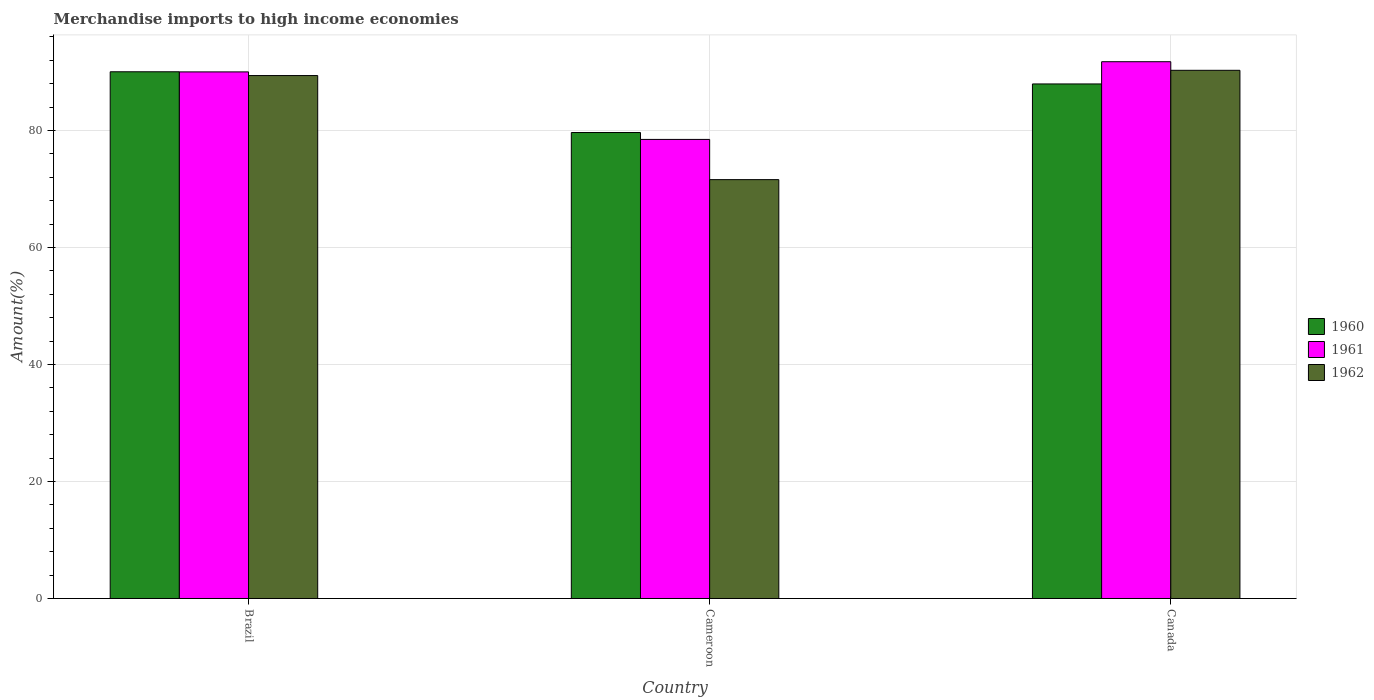How many groups of bars are there?
Provide a short and direct response. 3. Are the number of bars per tick equal to the number of legend labels?
Offer a very short reply. Yes. Are the number of bars on each tick of the X-axis equal?
Provide a short and direct response. Yes. How many bars are there on the 3rd tick from the left?
Your answer should be very brief. 3. In how many cases, is the number of bars for a given country not equal to the number of legend labels?
Give a very brief answer. 0. What is the percentage of amount earned from merchandise imports in 1962 in Brazil?
Ensure brevity in your answer.  89.41. Across all countries, what is the maximum percentage of amount earned from merchandise imports in 1960?
Offer a terse response. 90.05. Across all countries, what is the minimum percentage of amount earned from merchandise imports in 1961?
Provide a short and direct response. 78.49. In which country was the percentage of amount earned from merchandise imports in 1960 maximum?
Provide a succinct answer. Brazil. In which country was the percentage of amount earned from merchandise imports in 1962 minimum?
Your answer should be very brief. Cameroon. What is the total percentage of amount earned from merchandise imports in 1962 in the graph?
Your answer should be compact. 251.32. What is the difference between the percentage of amount earned from merchandise imports in 1962 in Brazil and that in Canada?
Provide a succinct answer. -0.9. What is the difference between the percentage of amount earned from merchandise imports in 1962 in Cameroon and the percentage of amount earned from merchandise imports in 1961 in Brazil?
Keep it short and to the point. -18.42. What is the average percentage of amount earned from merchandise imports in 1961 per country?
Give a very brief answer. 86.76. What is the difference between the percentage of amount earned from merchandise imports of/in 1961 and percentage of amount earned from merchandise imports of/in 1962 in Brazil?
Your response must be concise. 0.62. In how many countries, is the percentage of amount earned from merchandise imports in 1962 greater than 32 %?
Ensure brevity in your answer.  3. What is the ratio of the percentage of amount earned from merchandise imports in 1962 in Cameroon to that in Canada?
Give a very brief answer. 0.79. Is the percentage of amount earned from merchandise imports in 1961 in Brazil less than that in Cameroon?
Ensure brevity in your answer.  No. What is the difference between the highest and the second highest percentage of amount earned from merchandise imports in 1961?
Offer a terse response. -1.74. What is the difference between the highest and the lowest percentage of amount earned from merchandise imports in 1962?
Make the answer very short. 18.69. Is the sum of the percentage of amount earned from merchandise imports in 1962 in Brazil and Canada greater than the maximum percentage of amount earned from merchandise imports in 1960 across all countries?
Provide a short and direct response. Yes. Are all the bars in the graph horizontal?
Provide a succinct answer. No. What is the difference between two consecutive major ticks on the Y-axis?
Your answer should be very brief. 20. Are the values on the major ticks of Y-axis written in scientific E-notation?
Make the answer very short. No. What is the title of the graph?
Ensure brevity in your answer.  Merchandise imports to high income economies. Does "1988" appear as one of the legend labels in the graph?
Your answer should be very brief. No. What is the label or title of the X-axis?
Offer a very short reply. Country. What is the label or title of the Y-axis?
Your answer should be very brief. Amount(%). What is the Amount(%) in 1960 in Brazil?
Make the answer very short. 90.05. What is the Amount(%) in 1961 in Brazil?
Your answer should be very brief. 90.03. What is the Amount(%) in 1962 in Brazil?
Your response must be concise. 89.41. What is the Amount(%) in 1960 in Cameroon?
Provide a succinct answer. 79.67. What is the Amount(%) of 1961 in Cameroon?
Give a very brief answer. 78.49. What is the Amount(%) in 1962 in Cameroon?
Keep it short and to the point. 71.61. What is the Amount(%) of 1960 in Canada?
Offer a terse response. 87.97. What is the Amount(%) in 1961 in Canada?
Your response must be concise. 91.77. What is the Amount(%) of 1962 in Canada?
Ensure brevity in your answer.  90.3. Across all countries, what is the maximum Amount(%) of 1960?
Provide a succinct answer. 90.05. Across all countries, what is the maximum Amount(%) of 1961?
Offer a terse response. 91.77. Across all countries, what is the maximum Amount(%) of 1962?
Offer a terse response. 90.3. Across all countries, what is the minimum Amount(%) of 1960?
Your answer should be very brief. 79.67. Across all countries, what is the minimum Amount(%) in 1961?
Provide a short and direct response. 78.49. Across all countries, what is the minimum Amount(%) of 1962?
Offer a terse response. 71.61. What is the total Amount(%) in 1960 in the graph?
Your answer should be compact. 257.69. What is the total Amount(%) in 1961 in the graph?
Give a very brief answer. 260.29. What is the total Amount(%) in 1962 in the graph?
Make the answer very short. 251.32. What is the difference between the Amount(%) of 1960 in Brazil and that in Cameroon?
Your answer should be very brief. 10.38. What is the difference between the Amount(%) of 1961 in Brazil and that in Cameroon?
Your response must be concise. 11.54. What is the difference between the Amount(%) of 1962 in Brazil and that in Cameroon?
Make the answer very short. 17.8. What is the difference between the Amount(%) in 1960 in Brazil and that in Canada?
Give a very brief answer. 2.08. What is the difference between the Amount(%) in 1961 in Brazil and that in Canada?
Offer a terse response. -1.74. What is the difference between the Amount(%) in 1962 in Brazil and that in Canada?
Offer a terse response. -0.9. What is the difference between the Amount(%) of 1960 in Cameroon and that in Canada?
Ensure brevity in your answer.  -8.31. What is the difference between the Amount(%) in 1961 in Cameroon and that in Canada?
Make the answer very short. -13.28. What is the difference between the Amount(%) of 1962 in Cameroon and that in Canada?
Provide a short and direct response. -18.69. What is the difference between the Amount(%) of 1960 in Brazil and the Amount(%) of 1961 in Cameroon?
Offer a terse response. 11.56. What is the difference between the Amount(%) in 1960 in Brazil and the Amount(%) in 1962 in Cameroon?
Provide a succinct answer. 18.44. What is the difference between the Amount(%) of 1961 in Brazil and the Amount(%) of 1962 in Cameroon?
Offer a terse response. 18.42. What is the difference between the Amount(%) in 1960 in Brazil and the Amount(%) in 1961 in Canada?
Offer a very short reply. -1.72. What is the difference between the Amount(%) of 1960 in Brazil and the Amount(%) of 1962 in Canada?
Provide a short and direct response. -0.25. What is the difference between the Amount(%) of 1961 in Brazil and the Amount(%) of 1962 in Canada?
Your answer should be compact. -0.27. What is the difference between the Amount(%) of 1960 in Cameroon and the Amount(%) of 1961 in Canada?
Ensure brevity in your answer.  -12.11. What is the difference between the Amount(%) in 1960 in Cameroon and the Amount(%) in 1962 in Canada?
Offer a terse response. -10.64. What is the difference between the Amount(%) of 1961 in Cameroon and the Amount(%) of 1962 in Canada?
Provide a succinct answer. -11.82. What is the average Amount(%) of 1960 per country?
Give a very brief answer. 85.9. What is the average Amount(%) in 1961 per country?
Your response must be concise. 86.76. What is the average Amount(%) in 1962 per country?
Make the answer very short. 83.77. What is the difference between the Amount(%) of 1960 and Amount(%) of 1961 in Brazil?
Your answer should be very brief. 0.02. What is the difference between the Amount(%) in 1960 and Amount(%) in 1962 in Brazil?
Ensure brevity in your answer.  0.64. What is the difference between the Amount(%) in 1961 and Amount(%) in 1962 in Brazil?
Provide a short and direct response. 0.62. What is the difference between the Amount(%) in 1960 and Amount(%) in 1961 in Cameroon?
Ensure brevity in your answer.  1.18. What is the difference between the Amount(%) in 1960 and Amount(%) in 1962 in Cameroon?
Provide a succinct answer. 8.06. What is the difference between the Amount(%) of 1961 and Amount(%) of 1962 in Cameroon?
Ensure brevity in your answer.  6.88. What is the difference between the Amount(%) in 1960 and Amount(%) in 1961 in Canada?
Your answer should be very brief. -3.8. What is the difference between the Amount(%) in 1960 and Amount(%) in 1962 in Canada?
Keep it short and to the point. -2.33. What is the difference between the Amount(%) of 1961 and Amount(%) of 1962 in Canada?
Your answer should be compact. 1.47. What is the ratio of the Amount(%) of 1960 in Brazil to that in Cameroon?
Provide a succinct answer. 1.13. What is the ratio of the Amount(%) in 1961 in Brazil to that in Cameroon?
Keep it short and to the point. 1.15. What is the ratio of the Amount(%) of 1962 in Brazil to that in Cameroon?
Your answer should be very brief. 1.25. What is the ratio of the Amount(%) in 1960 in Brazil to that in Canada?
Ensure brevity in your answer.  1.02. What is the ratio of the Amount(%) in 1962 in Brazil to that in Canada?
Offer a terse response. 0.99. What is the ratio of the Amount(%) of 1960 in Cameroon to that in Canada?
Offer a very short reply. 0.91. What is the ratio of the Amount(%) in 1961 in Cameroon to that in Canada?
Your response must be concise. 0.86. What is the ratio of the Amount(%) of 1962 in Cameroon to that in Canada?
Offer a very short reply. 0.79. What is the difference between the highest and the second highest Amount(%) in 1960?
Make the answer very short. 2.08. What is the difference between the highest and the second highest Amount(%) of 1961?
Your answer should be very brief. 1.74. What is the difference between the highest and the second highest Amount(%) of 1962?
Keep it short and to the point. 0.9. What is the difference between the highest and the lowest Amount(%) in 1960?
Offer a terse response. 10.38. What is the difference between the highest and the lowest Amount(%) in 1961?
Your response must be concise. 13.28. What is the difference between the highest and the lowest Amount(%) of 1962?
Your answer should be very brief. 18.69. 